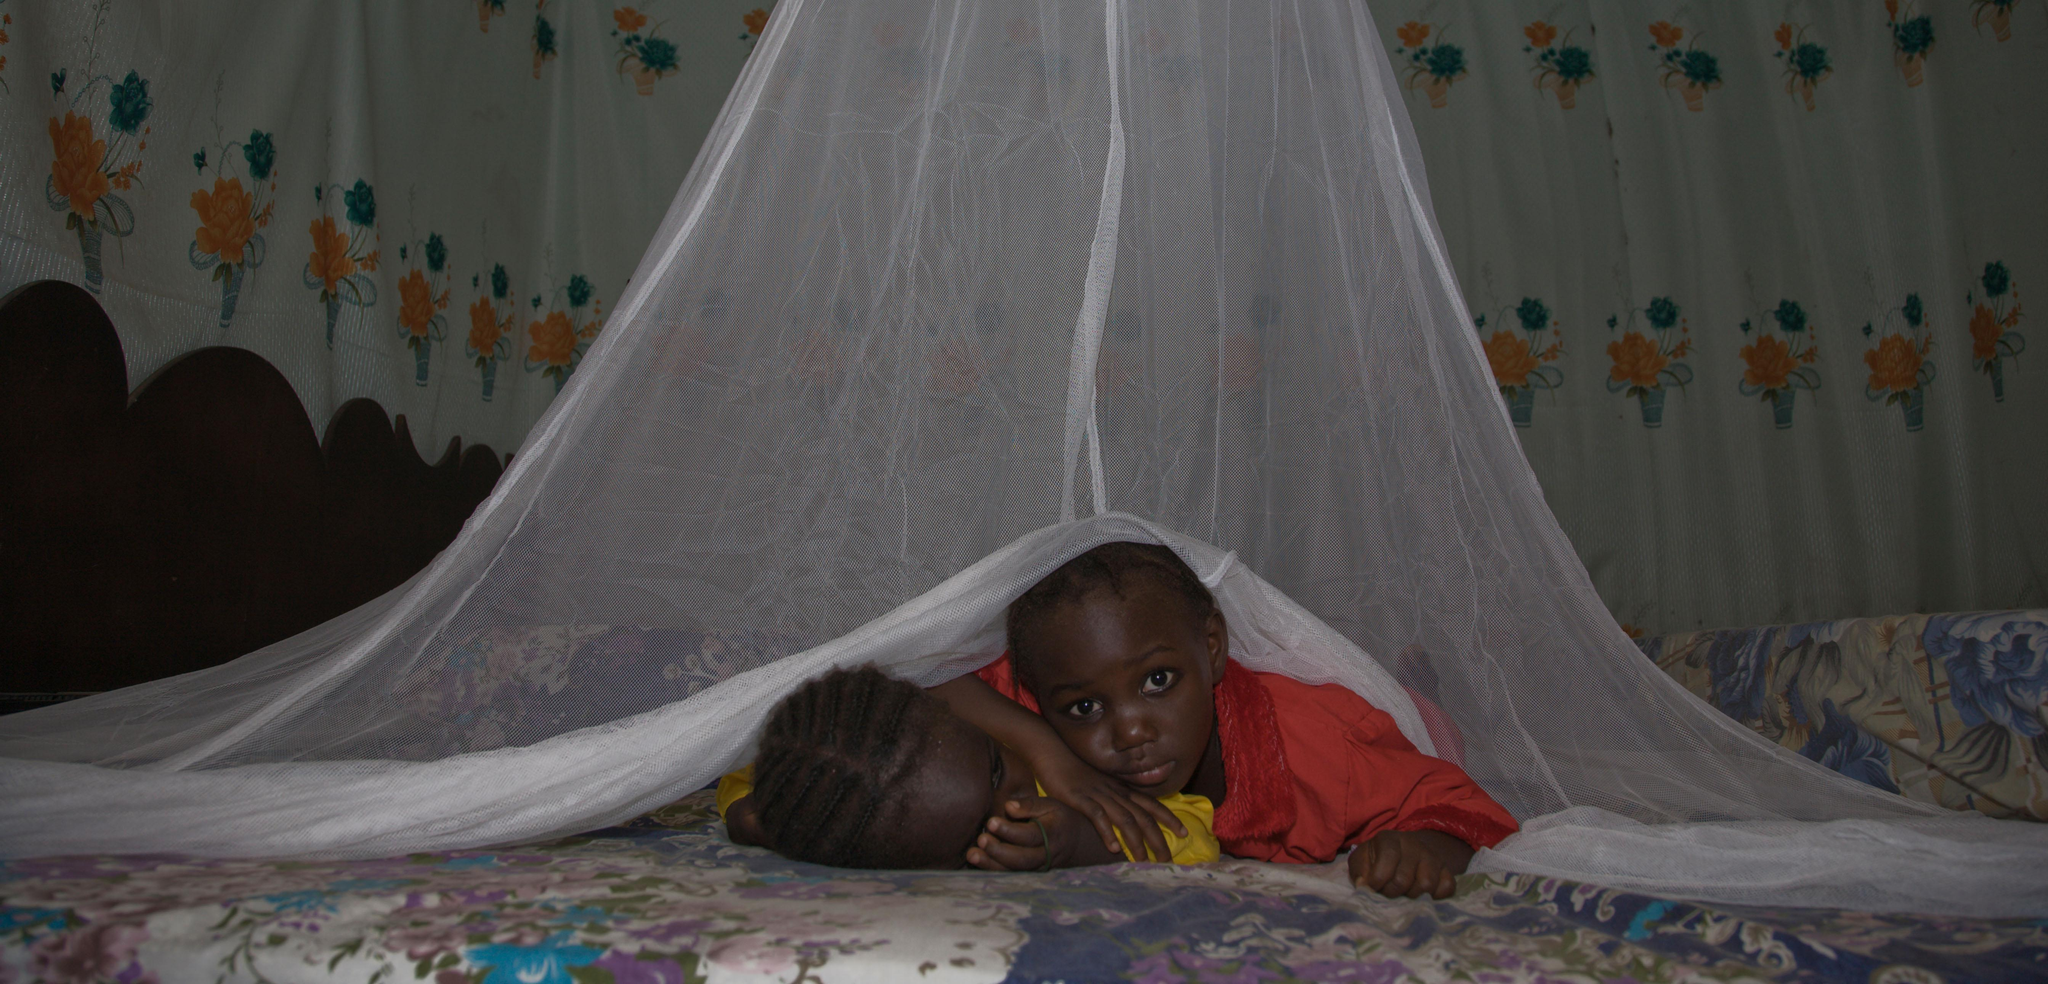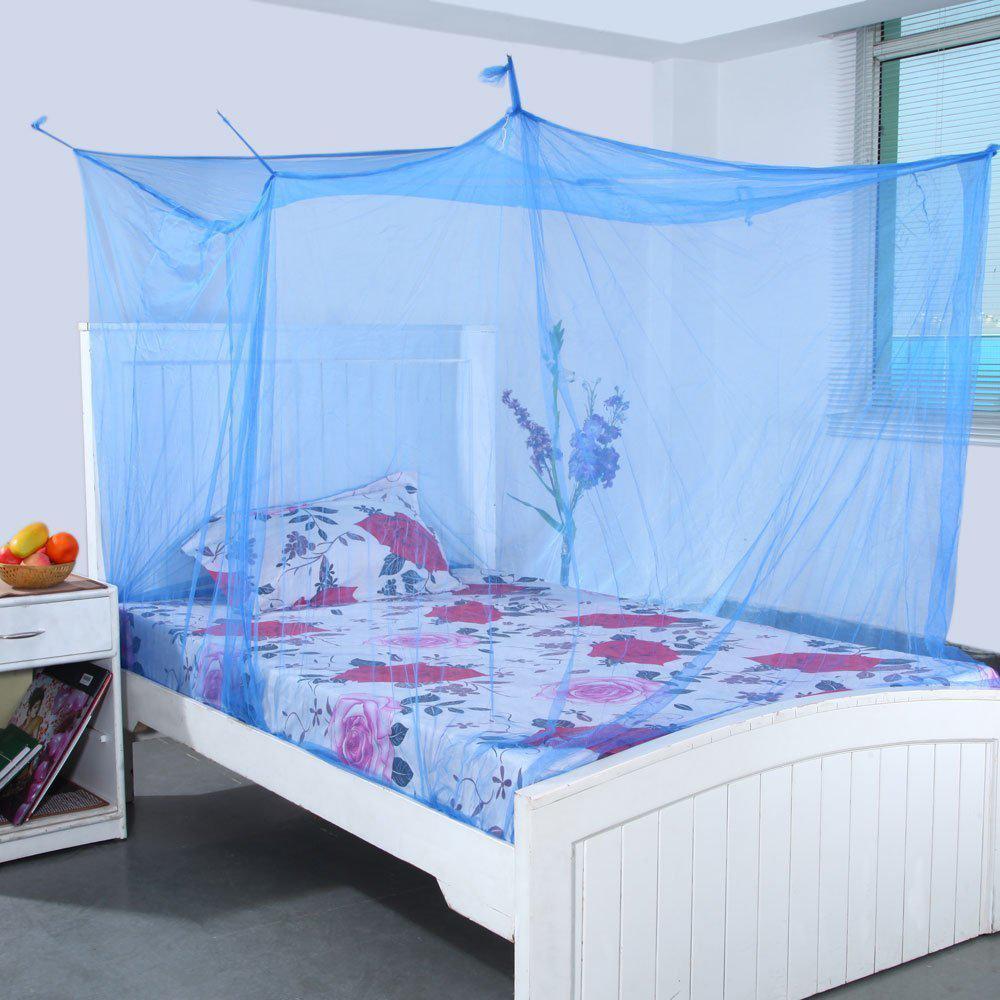The first image is the image on the left, the second image is the image on the right. Evaluate the accuracy of this statement regarding the images: "All the nets are blue.". Is it true? Answer yes or no. No. The first image is the image on the left, the second image is the image on the right. For the images displayed, is the sentence "The bed draperies in each image are similar in color and suspended from a circular framework over the bed." factually correct? Answer yes or no. No. 